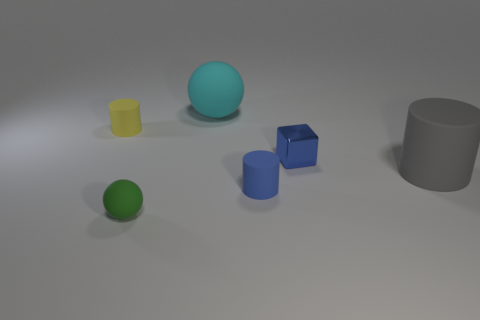Do the matte cylinder behind the large gray matte cylinder and the small rubber ball have the same color?
Offer a very short reply. No. How many green rubber objects have the same shape as the gray rubber object?
Your response must be concise. 0. Is the number of blue matte objects that are right of the large gray matte cylinder the same as the number of small green matte balls?
Provide a short and direct response. No. There is another object that is the same size as the gray rubber thing; what is its color?
Your answer should be very brief. Cyan. Is there a cyan object that has the same shape as the gray object?
Offer a very short reply. No. The sphere in front of the cylinder to the left of the matte sphere on the left side of the cyan rubber object is made of what material?
Give a very brief answer. Rubber. What number of other objects are there of the same size as the green matte ball?
Your response must be concise. 3. What is the color of the big ball?
Your answer should be compact. Cyan. How many metallic objects are large green objects or tiny yellow cylinders?
Your answer should be compact. 0. Are there any other things that have the same material as the blue cube?
Offer a very short reply. No. 